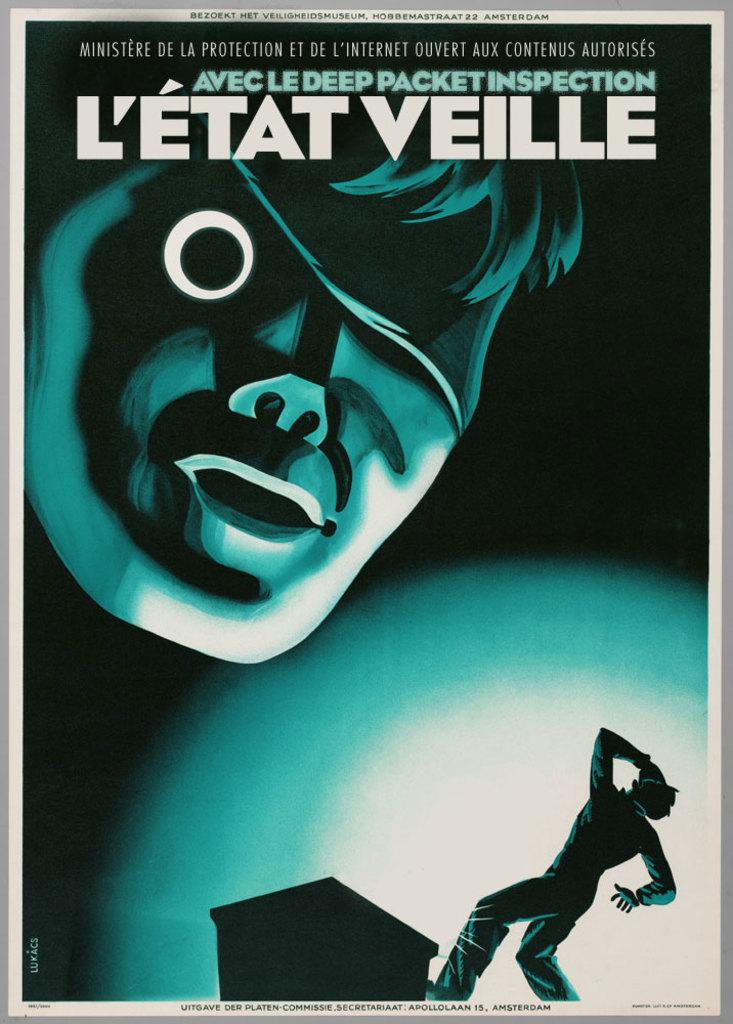What type of picture is featured in the image? The image contains an animated picture. Can you describe the text at the top of the image? There is text at the top of the image. Is there any text located elsewhere in the image? Yes, there is text at the bottom of the image as well. What kind of characters can be seen in the image? There are cartoons present in the image. What type of army is depicted in the image? There is no army present in the image; it features an animated picture with text and cartoons. How does the knee of the cartoon character appear in the image? There are no cartoon characters with knees visible in the image, as the cartoons present are not detailed enough to show such features. 